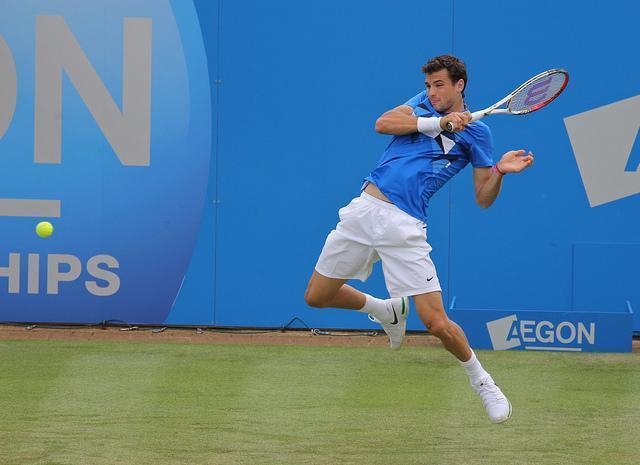How many bottle caps are in the photo?
Give a very brief answer. 0. 